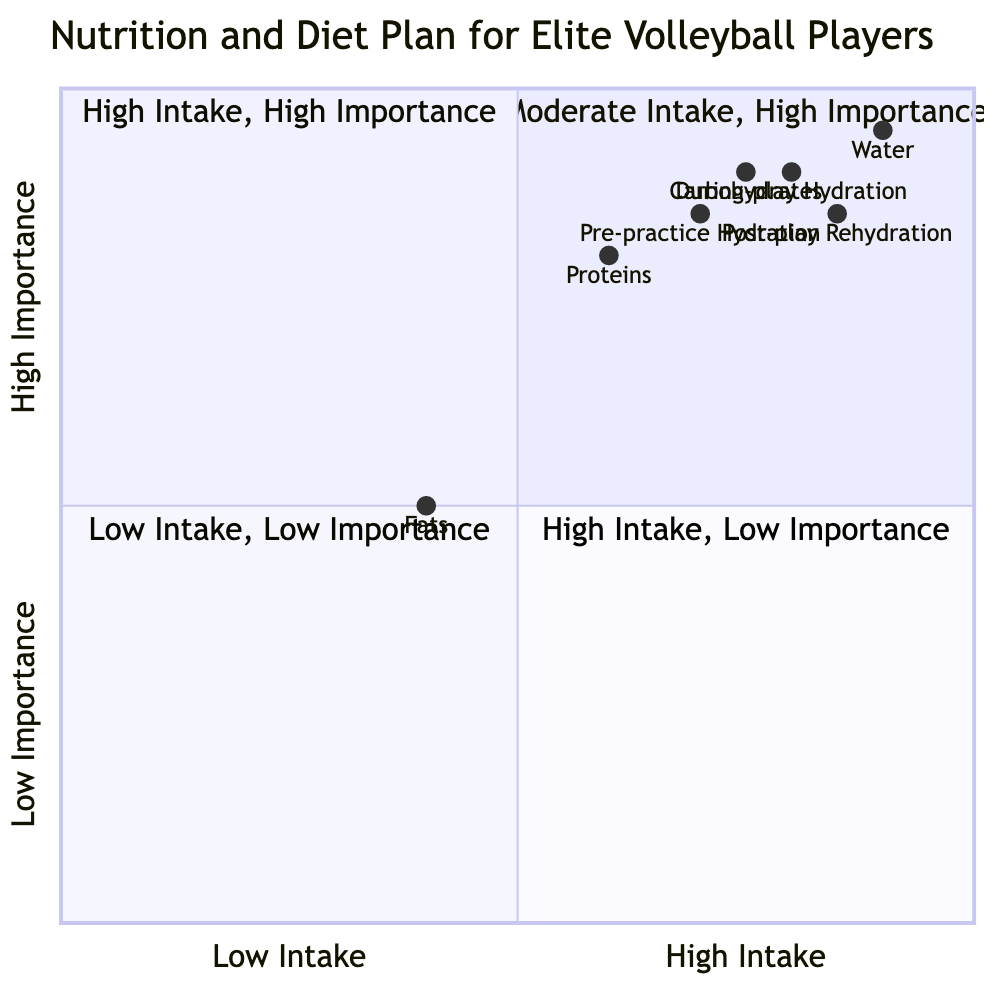What is the recommended hydration level before practice? The diagram indicates that the recommended hydration level for "Pre-practice Hydration" is in the range of 0.7 to 0.85. The average of these values gives an approximate value of 0.775.
Answer: 0.7 to 0.85 Which macronutrient has the highest importance level in this diagram? The hydration strategy labeled "Water" has the highest placement on the y-axis with a value range of 0.9 to 0.95, indicating both high intake and high importance compared to other nutrients.
Answer: Water What is the intake importance relationship for fats? Fats are represented in quadrant 4 where both intake and importance are low, with the intake value ranging from 0.4 to 0.5 and lower importance compared to other nutrients.
Answer: Low How does the intake of carbohydrates compare to proteins? Carbohydrates have a moderate to high intake range of 0.75 to 0.9, while proteins have a lower intake range of 0.6 to 0.8, placing carbohydrates at a higher intake level than proteins.
Answer: Higher What is the recommended hydration level during play? The diagram states that "During-play Hydration" has a recommended hydration level between 0.8 to 0.9, highlighting the need for adequate hydration during the game.
Answer: 0.8 to 0.9 Which quadrant do proteins fall into regarding importance? Proteins are located in quadrant 2, which indicates both moderate intake (0.6 to 0.8) and high importance, making them essential for elite volleyball players.
Answer: Quadrant 2 What is the post-play rehydration value? The hydration strategy for "Post-play Rehydration" shows a value of 0.85, indicating a slightly high intake level after play to restore fluids.
Answer: 0.85 Which nutrient has the lowest value for both intake and importance? Fats have the lowest values on both axes, categorized in quadrant 4 indicating low performance and low importance compared to the other nutrients listed.
Answer: Fats 